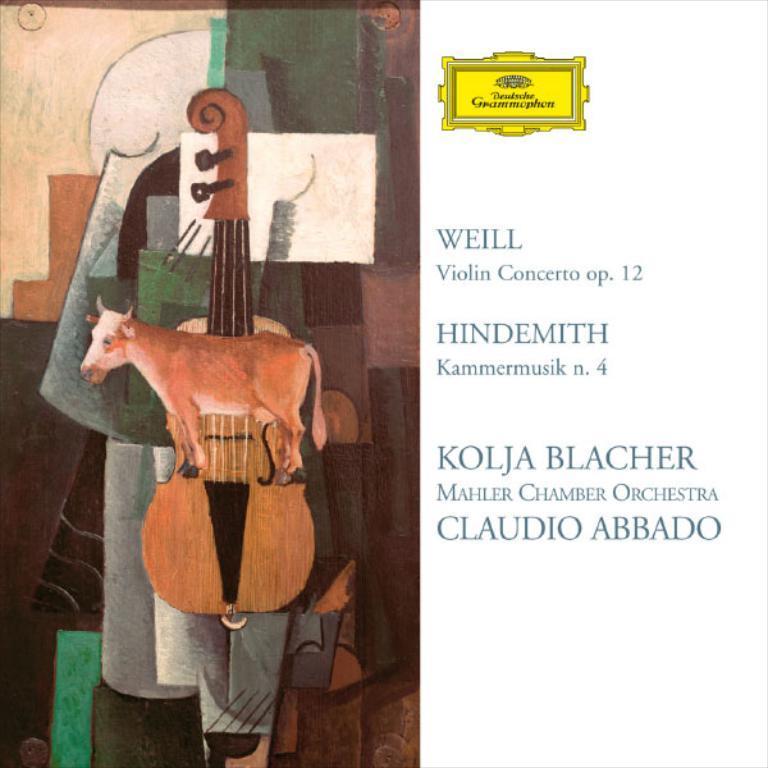In one or two sentences, can you explain what this image depicts? On the left side of the image we can see the depiction of an animal, guitar, board and also some objects. On the right we can see the text. 